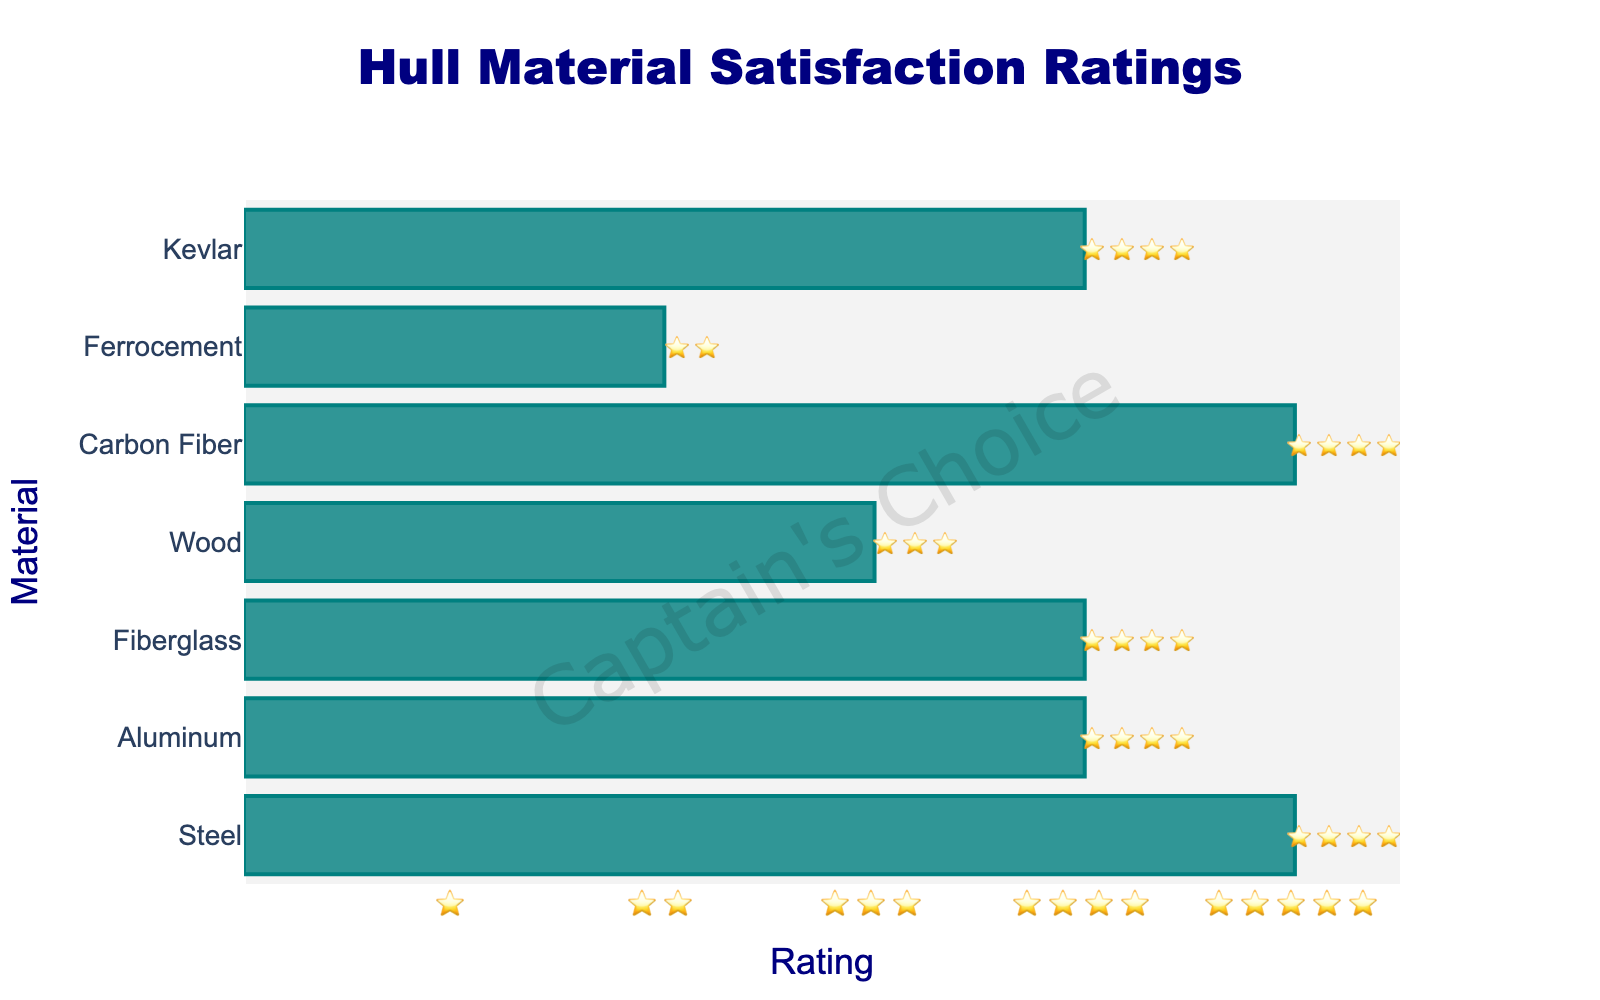What's the title of the chart? The title of the chart is displayed at the top and says, "Hull Material Satisfaction Ratings."
Answer: Hull Material Satisfaction Ratings Which hull material showed the highest satisfaction rating? The highest satisfaction ratings are indicated with 5 stars. Both Steel and Carbon Fiber have 5-star ratings.
Answer: Steel, Carbon Fiber How many materials have 4-star ratings? By counting the number of materials that have 4 stars next to them, we find three materials have 4 stars: Aluminum, Fiberglass, and Kevlar.
Answer: 3 Which material has the lowest satisfaction rating? The lowest satisfaction rating is indicated with the fewest stars. Ferrocement has the lowest rating with 2 stars.
Answer: Ferrocement Which materials have satisfaction ratings greater than Wood's rating? Wood has a 3-star rating. Counting all materials with more than 3 stars: Steel, Aluminum, Fiberglass, Carbon Fiber, and Kevlar have greater ratings.
Answer: Steel, Aluminum, Fiberglass, Carbon Fiber, Kevlar What's the average rating of all the materials? First, convert star ratings to numbers: Steel (5), Aluminum (4), Fiberglass (4), Wood (3), Carbon Fiber (5), Ferrocement (2), and Kevlar (4). Sum them up: 5 + 4 + 4 + 3 + 5 + 2 + 4 = 27. There are 7 materials, so the average is 27/7 = 3.86.
Answer: 3.86 How many materials have a satisfaction rating of 5 stars? By counting the number of materials with 5-star ratings, we see there are two materials: Steel and Carbon Fiber.
Answer: 2 Which material has a satisfaction rating one star higher than Wood's rating? Wood has a 3-star rating. One star higher would be 4 stars. The materials with 4 stars are Aluminum, Fiberglass, and Kevlar.
Answer: Aluminum, Fiberglass, Kevlar What can you say about the uniformity of the ratings in the chart? The ratings in the chart vary from 2 stars to 5 stars, indicating a wide range of satisfaction levels across different materials.
Answer: Wide range What is the combined satisfaction rating of Steel and Carbon Fiber? Both Steel and Carbon Fiber have 5-star ratings. Combined, that's 5 + 5 = 10 stars.
Answer: 10 